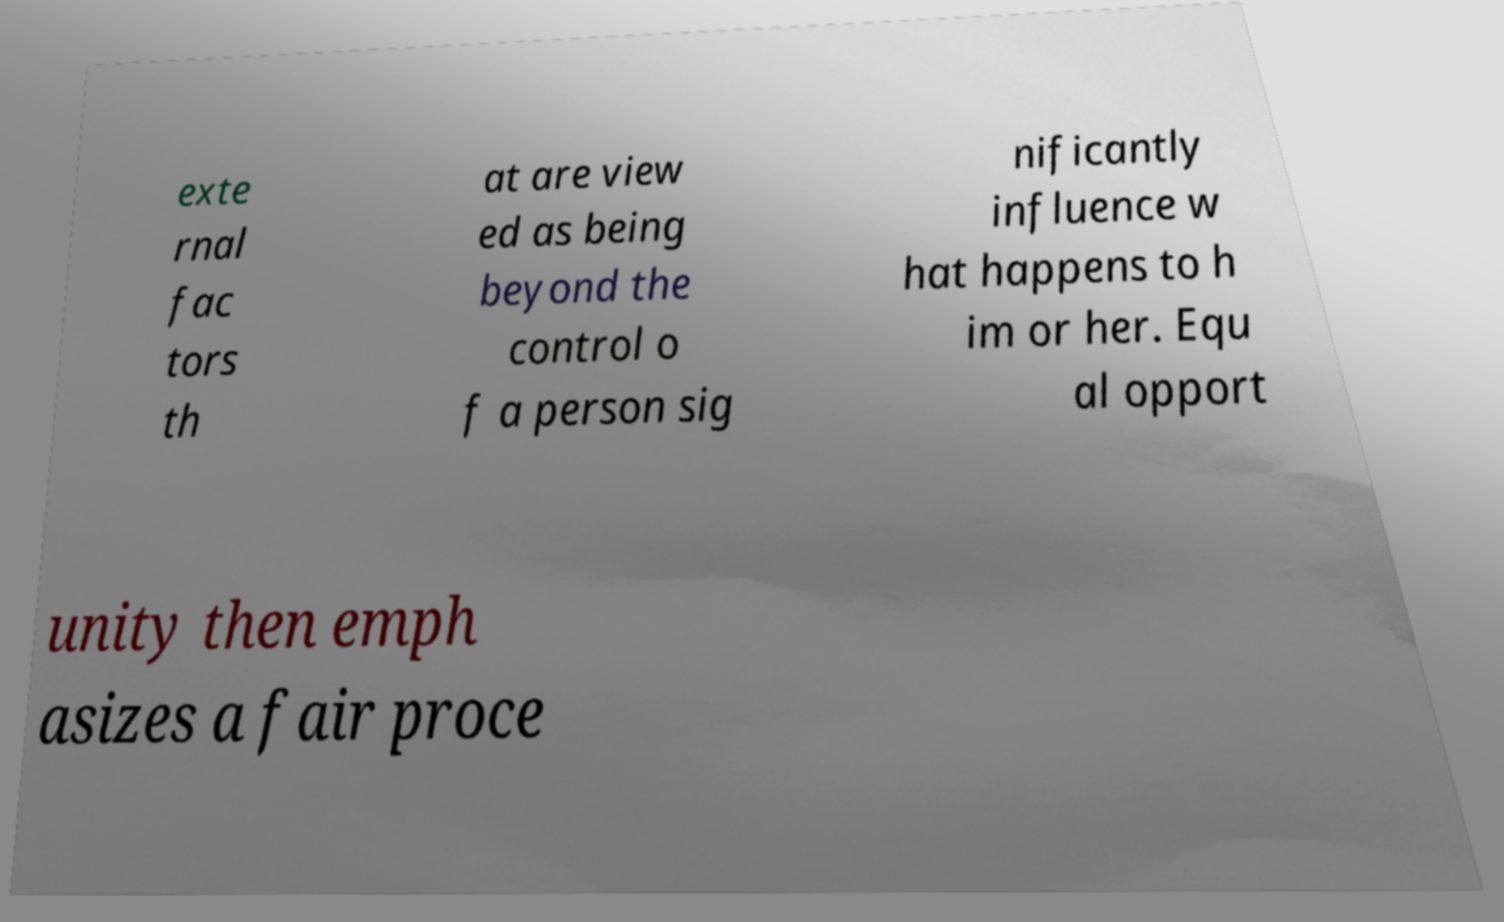Can you read and provide the text displayed in the image?This photo seems to have some interesting text. Can you extract and type it out for me? exte rnal fac tors th at are view ed as being beyond the control o f a person sig nificantly influence w hat happens to h im or her. Equ al opport unity then emph asizes a fair proce 